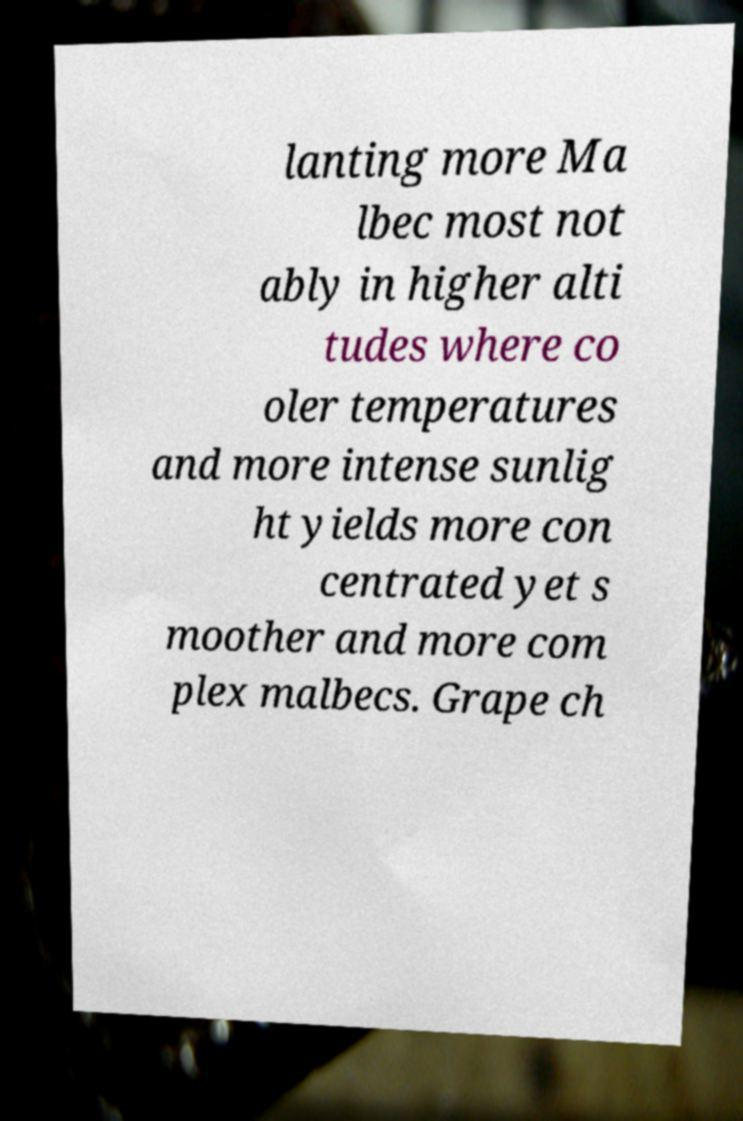Can you accurately transcribe the text from the provided image for me? lanting more Ma lbec most not ably in higher alti tudes where co oler temperatures and more intense sunlig ht yields more con centrated yet s moother and more com plex malbecs. Grape ch 